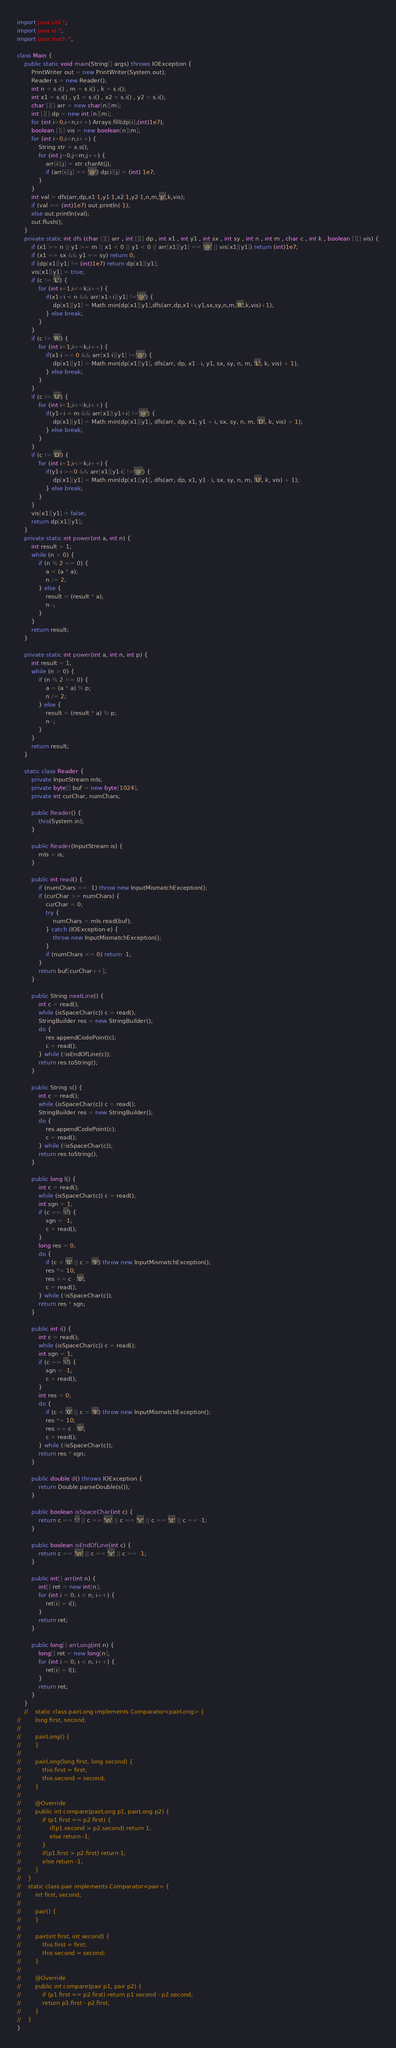<code> <loc_0><loc_0><loc_500><loc_500><_Java_>
import java.util.*;
import java.io.*;
import java.math.*;

class Main {
    public static void main(String[] args) throws IOException {
        PrintWriter out = new PrintWriter(System.out);
        Reader s = new Reader();
        int n = s.i() , m = s.i() , k = s.i();
        int x1 = s.i() , y1 = s.i() , x2 = s.i() , y2 = s.i();
        char [][] arr = new char[n][m];
        int [][] dp = new int [n][m];
        for (int i=0;i<n;i++) Arrays.fill(dp[i],(int)1e7);
        boolean [][] vis = new boolean[n][m];
        for (int i=0;i<n;i++) {
            String str = s.s();
            for (int j=0;j<m;j++) {
                arr[i][j] = str.charAt(j);
                if (arr[i][j] == '@') dp[i][j] = (int) 1e7;
            }
        }
        int val = dfs(arr,dp,x1-1,y1-1,x2-1,y2-1,n,m,'p',k,vis);
        if (val == (int)1e7) out.println(-1);
        else out.println(val);
        out.flush();
    }
    private static int dfs (char [][] arr , int [][] dp , int x1 , int y1 , int sx , int sy , int n , int m , char c , int k , boolean [][] vis) {
        if (x1 >= n || y1 >= m || x1 < 0 || y1 < 0 || arr[x1][y1] == '@' || vis[x1][y1]) return (int)1e7;
        if (x1 == sx && y1 == sy) return 0;
        if (dp[x1][y1] != (int)1e7) return dp[x1][y1];
        vis[x1][y1] = true;
        if (c != 'L') {
            for (int i=1;i<=k;i++) {
                if(x1+i < n && arr[x1+i][y1] !='@') {
                    dp[x1][y1] = Math.min(dp[x1][y1],dfs(arr,dp,x1+i,y1,sx,sy,n,m,'R',k,vis)+1);
                } else break;
            }
        }
        if (c != 'R') {
            for (int i=1;i<=k;i++) {
                if(x1-i >= 0 && arr[x1-i][y1] !='@') {
                    dp[x1][y1] = Math.min(dp[x1][y1], dfs(arr, dp, x1 - i, y1, sx, sy, n, m, 'L', k, vis) + 1);
                } else break;
            }
        }
        if (c != 'U') {
            for (int i=1;i<=k;i++) {
                if(y1+i < m && arr[x1][y1+i] !='@') {
                    dp[x1][y1] = Math.min(dp[x1][y1], dfs(arr, dp, x1, y1 + i, sx, sy, n, m, 'D', k, vis) + 1);
                } else break;
            }
        }
        if (c != 'D') {
            for (int i=1;i<=k;i++) {
                if(y1-i >=0 && arr[x1][y1-i] !='@') {
                    dp[x1][y1] = Math.min(dp[x1][y1], dfs(arr, dp, x1, y1 - i, sx, sy, n, m, 'U', k, vis) + 1);
                } else break;
            }
        }
        vis[x1][y1] = false;
        return dp[x1][y1];
    }
    private static int power(int a, int n) {
        int result = 1;
        while (n > 0) {
            if (n % 2 == 0) {
                a = (a * a);
                n /= 2;
            } else {
                result = (result * a);
                n--;
            }
        }
        return result;
    }

    private static int power(int a, int n, int p) {
        int result = 1;
        while (n > 0) {
            if (n % 2 == 0) {
                a = (a * a) % p;
                n /= 2;
            } else {
                result = (result * a) % p;
                n--;
            }
        }
        return result;
    }

    static class Reader {
        private InputStream mIs;
        private byte[] buf = new byte[1024];
        private int curChar, numChars;

        public Reader() {
            this(System.in);
        }

        public Reader(InputStream is) {
            mIs = is;
        }

        public int read() {
            if (numChars == -1) throw new InputMismatchException();
            if (curChar >= numChars) {
                curChar = 0;
                try {
                    numChars = mIs.read(buf);
                } catch (IOException e) {
                    throw new InputMismatchException();
                }
                if (numChars <= 0) return -1;
            }
            return buf[curChar++];
        }

        public String nextLine() {
            int c = read();
            while (isSpaceChar(c)) c = read();
            StringBuilder res = new StringBuilder();
            do {
                res.appendCodePoint(c);
                c = read();
            } while (!isEndOfLine(c));
            return res.toString();
        }

        public String s() {
            int c = read();
            while (isSpaceChar(c)) c = read();
            StringBuilder res = new StringBuilder();
            do {
                res.appendCodePoint(c);
                c = read();
            } while (!isSpaceChar(c));
            return res.toString();
        }

        public long l() {
            int c = read();
            while (isSpaceChar(c)) c = read();
            int sgn = 1;
            if (c == '-') {
                sgn = -1;
                c = read();
            }
            long res = 0;
            do {
                if (c < '0' || c > '9') throw new InputMismatchException();
                res *= 10;
                res += c - '0';
                c = read();
            } while (!isSpaceChar(c));
            return res * sgn;
        }

        public int i() {
            int c = read();
            while (isSpaceChar(c)) c = read();
            int sgn = 1;
            if (c == '-') {
                sgn = -1;
                c = read();
            }
            int res = 0;
            do {
                if (c < '0' || c > '9') throw new InputMismatchException();
                res *= 10;
                res += c - '0';
                c = read();
            } while (!isSpaceChar(c));
            return res * sgn;
        }

        public double d() throws IOException {
            return Double.parseDouble(s());
        }

        public boolean isSpaceChar(int c) {
            return c == ' ' || c == '\n' || c == '\r' || c == '\t' || c == -1;
        }

        public boolean isEndOfLine(int c) {
            return c == '\n' || c == '\r' || c == -1;
        }

        public int[] arr(int n) {
            int[] ret = new int[n];
            for (int i = 0; i < n; i++) {
                ret[i] = i();
            }
            return ret;
        }

        public long[] arrLong(int n) {
            long[] ret = new long[n];
            for (int i = 0; i < n; i++) {
                ret[i] = l();
            }
            return ret;
        }
    }
    //    static class pairLong implements Comparator<pairLong> {
//        long first, second;
//
//        pairLong() {
//        }
//
//        pairLong(long first, long second) {
//            this.first = first;
//            this.second = second;
//        }
//
//        @Override
//        public int compare(pairLong p1, pairLong p2) {
//            if (p1.first == p2.first) {
//                if(p1.second > p2.second) return 1;
//                else return -1;
//            }
//            if(p1.first > p2.first) return 1;
//            else return -1;
//        }
//    }
//    static class pair implements Comparator<pair> {
//        int first, second;
//
//        pair() {
//        }
//
//        pair(int first, int second) {
//            this.first = first;
//            this.second = second;
//        }
//
//        @Override
//        public int compare(pair p1, pair p2) {
//            if (p1.first == p2.first) return p1.second - p2.second;
//            return p1.first - p2.first;
//        }
//    }
}
</code> 